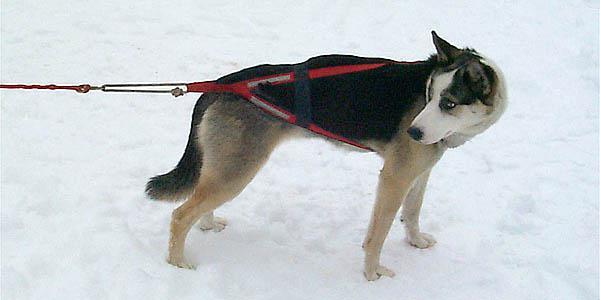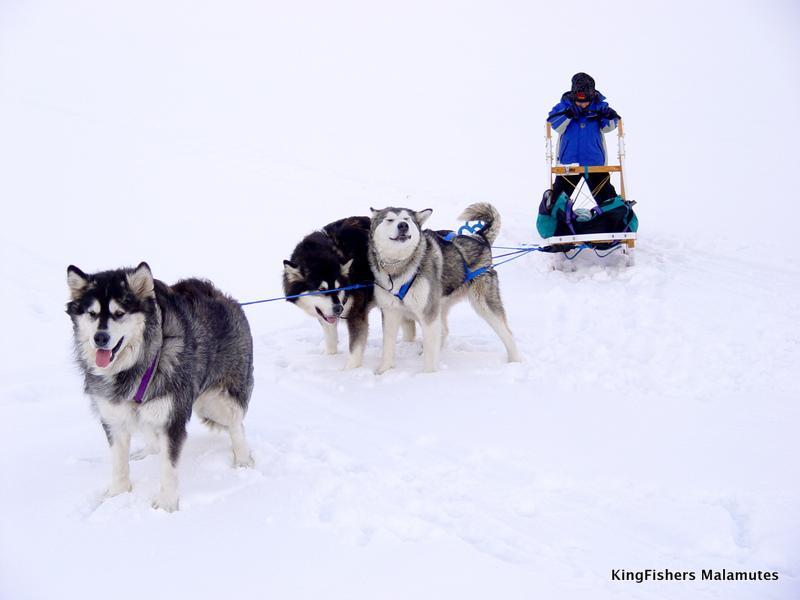The first image is the image on the left, the second image is the image on the right. For the images displayed, is the sentence "An image shows a multicolored dog wearing a red harness that extends out of the snowy scene." factually correct? Answer yes or no. Yes. The first image is the image on the left, the second image is the image on the right. Analyze the images presented: Is the assertion "The left image contains exactly one dog." valid? Answer yes or no. Yes. 